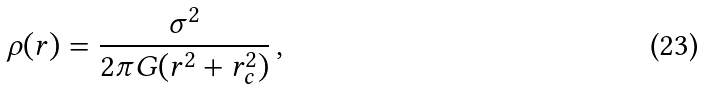Convert formula to latex. <formula><loc_0><loc_0><loc_500><loc_500>\rho ( r ) = \frac { \sigma ^ { 2 } } { 2 \pi G ( r ^ { 2 } + r _ { c } ^ { 2 } ) } \, ,</formula> 